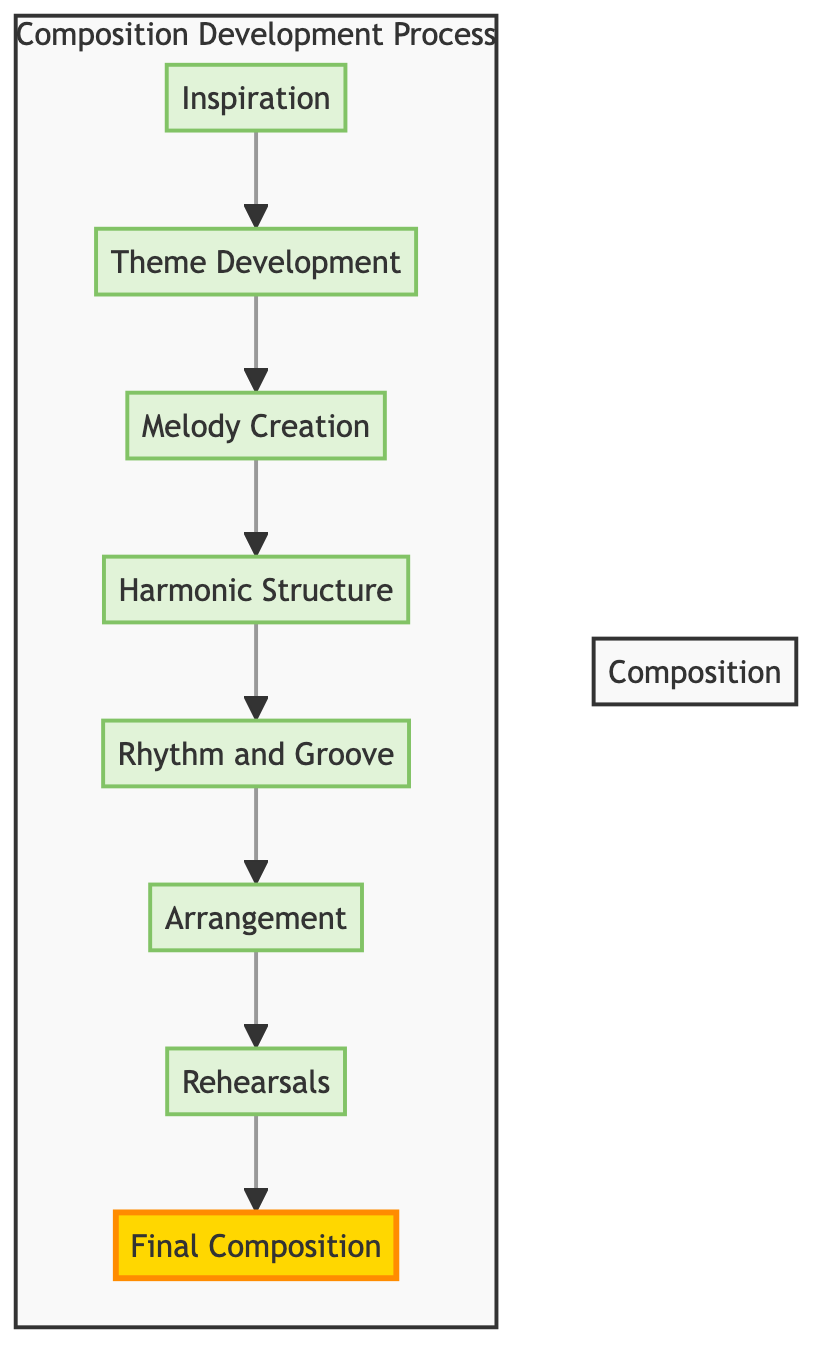What is the first step in the composition development process? The first step in the diagram is labeled "Inspiration," which is located at the top of the flow chart.
Answer: Inspiration How many steps are there in the composition development process? By counting the nodes in the diagram from "Inspiration" to "Final Composition," there are a total of eight steps.
Answer: 8 What is the final step in the composition development process? The final step is labeled "Final Composition," which is the last node in the flow from top to bottom in the diagram.
Answer: Final Composition Which step follows "Melody Creation"? "Harmonic Structure" directly connects to "Melody Creation" as the next step, indicating the progression in the flow.
Answer: Harmonic Structure What two elements are connected directly to "Arrangement"? The step preceding "Arrangement" is "Rhythm and Groove," and it connects to the subsequent step "Rehearsals," indicating both elements are directly connected to it.
Answer: Rhythm and Groove, Rehearsals What influences are incorporated into "Rhythm and Groove"? The description for "Rhythm and Groove" mentions integrating influences from world music, indicating a blend of varied rhythmic patterns.
Answer: World music What is the significance of the highlight used in the diagram? The highlight is applied to "Final Composition" to emphasize it as the concluding step in the entire composition development process.
Answer: Significance of concluding step Which step focuses on collaborating with musicians? "Rehearsals" is the step that emphasizes collaboration with musicians to refine the compositions further.
Answer: Rehearsals In which step would you address transitions and dynamics? The step "Final Composition" is where transitions, dynamics, and overall flow are polished before a performance or recording.
Answer: Final Composition 